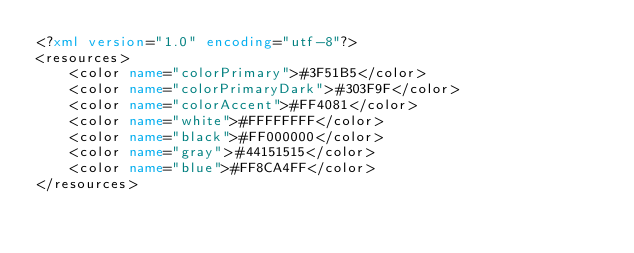Convert code to text. <code><loc_0><loc_0><loc_500><loc_500><_XML_><?xml version="1.0" encoding="utf-8"?>
<resources>
    <color name="colorPrimary">#3F51B5</color>
    <color name="colorPrimaryDark">#303F9F</color>
    <color name="colorAccent">#FF4081</color>
    <color name="white">#FFFFFFFF</color>
    <color name="black">#FF000000</color>
    <color name="gray">#44151515</color>
    <color name="blue">#FF8CA4FF</color>
</resources>
</code> 